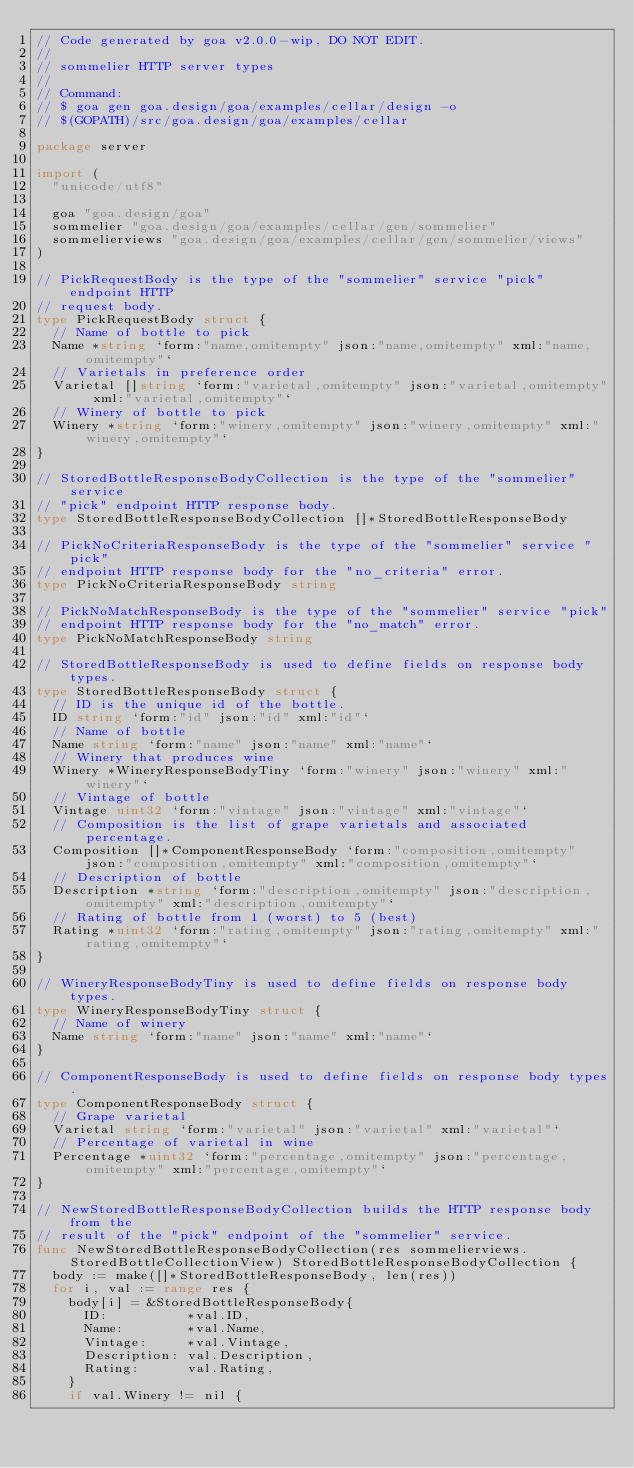Convert code to text. <code><loc_0><loc_0><loc_500><loc_500><_Go_>// Code generated by goa v2.0.0-wip, DO NOT EDIT.
//
// sommelier HTTP server types
//
// Command:
// $ goa gen goa.design/goa/examples/cellar/design -o
// $(GOPATH)/src/goa.design/goa/examples/cellar

package server

import (
	"unicode/utf8"

	goa "goa.design/goa"
	sommelier "goa.design/goa/examples/cellar/gen/sommelier"
	sommelierviews "goa.design/goa/examples/cellar/gen/sommelier/views"
)

// PickRequestBody is the type of the "sommelier" service "pick" endpoint HTTP
// request body.
type PickRequestBody struct {
	// Name of bottle to pick
	Name *string `form:"name,omitempty" json:"name,omitempty" xml:"name,omitempty"`
	// Varietals in preference order
	Varietal []string `form:"varietal,omitempty" json:"varietal,omitempty" xml:"varietal,omitempty"`
	// Winery of bottle to pick
	Winery *string `form:"winery,omitempty" json:"winery,omitempty" xml:"winery,omitempty"`
}

// StoredBottleResponseBodyCollection is the type of the "sommelier" service
// "pick" endpoint HTTP response body.
type StoredBottleResponseBodyCollection []*StoredBottleResponseBody

// PickNoCriteriaResponseBody is the type of the "sommelier" service "pick"
// endpoint HTTP response body for the "no_criteria" error.
type PickNoCriteriaResponseBody string

// PickNoMatchResponseBody is the type of the "sommelier" service "pick"
// endpoint HTTP response body for the "no_match" error.
type PickNoMatchResponseBody string

// StoredBottleResponseBody is used to define fields on response body types.
type StoredBottleResponseBody struct {
	// ID is the unique id of the bottle.
	ID string `form:"id" json:"id" xml:"id"`
	// Name of bottle
	Name string `form:"name" json:"name" xml:"name"`
	// Winery that produces wine
	Winery *WineryResponseBodyTiny `form:"winery" json:"winery" xml:"winery"`
	// Vintage of bottle
	Vintage uint32 `form:"vintage" json:"vintage" xml:"vintage"`
	// Composition is the list of grape varietals and associated percentage.
	Composition []*ComponentResponseBody `form:"composition,omitempty" json:"composition,omitempty" xml:"composition,omitempty"`
	// Description of bottle
	Description *string `form:"description,omitempty" json:"description,omitempty" xml:"description,omitempty"`
	// Rating of bottle from 1 (worst) to 5 (best)
	Rating *uint32 `form:"rating,omitempty" json:"rating,omitempty" xml:"rating,omitempty"`
}

// WineryResponseBodyTiny is used to define fields on response body types.
type WineryResponseBodyTiny struct {
	// Name of winery
	Name string `form:"name" json:"name" xml:"name"`
}

// ComponentResponseBody is used to define fields on response body types.
type ComponentResponseBody struct {
	// Grape varietal
	Varietal string `form:"varietal" json:"varietal" xml:"varietal"`
	// Percentage of varietal in wine
	Percentage *uint32 `form:"percentage,omitempty" json:"percentage,omitempty" xml:"percentage,omitempty"`
}

// NewStoredBottleResponseBodyCollection builds the HTTP response body from the
// result of the "pick" endpoint of the "sommelier" service.
func NewStoredBottleResponseBodyCollection(res sommelierviews.StoredBottleCollectionView) StoredBottleResponseBodyCollection {
	body := make([]*StoredBottleResponseBody, len(res))
	for i, val := range res {
		body[i] = &StoredBottleResponseBody{
			ID:          *val.ID,
			Name:        *val.Name,
			Vintage:     *val.Vintage,
			Description: val.Description,
			Rating:      val.Rating,
		}
		if val.Winery != nil {</code> 